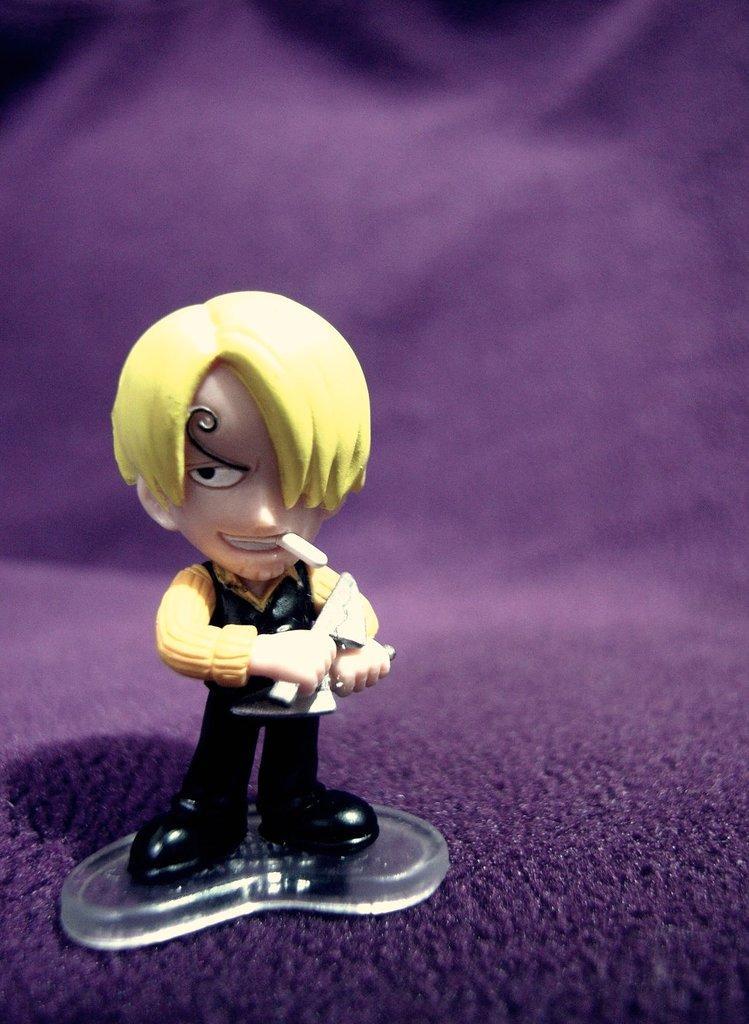Describe this image in one or two sentences. In this image I can see the toy in yellow, cream and black color. Background is in purple color. 